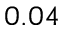<formula> <loc_0><loc_0><loc_500><loc_500>0 . 0 4</formula> 